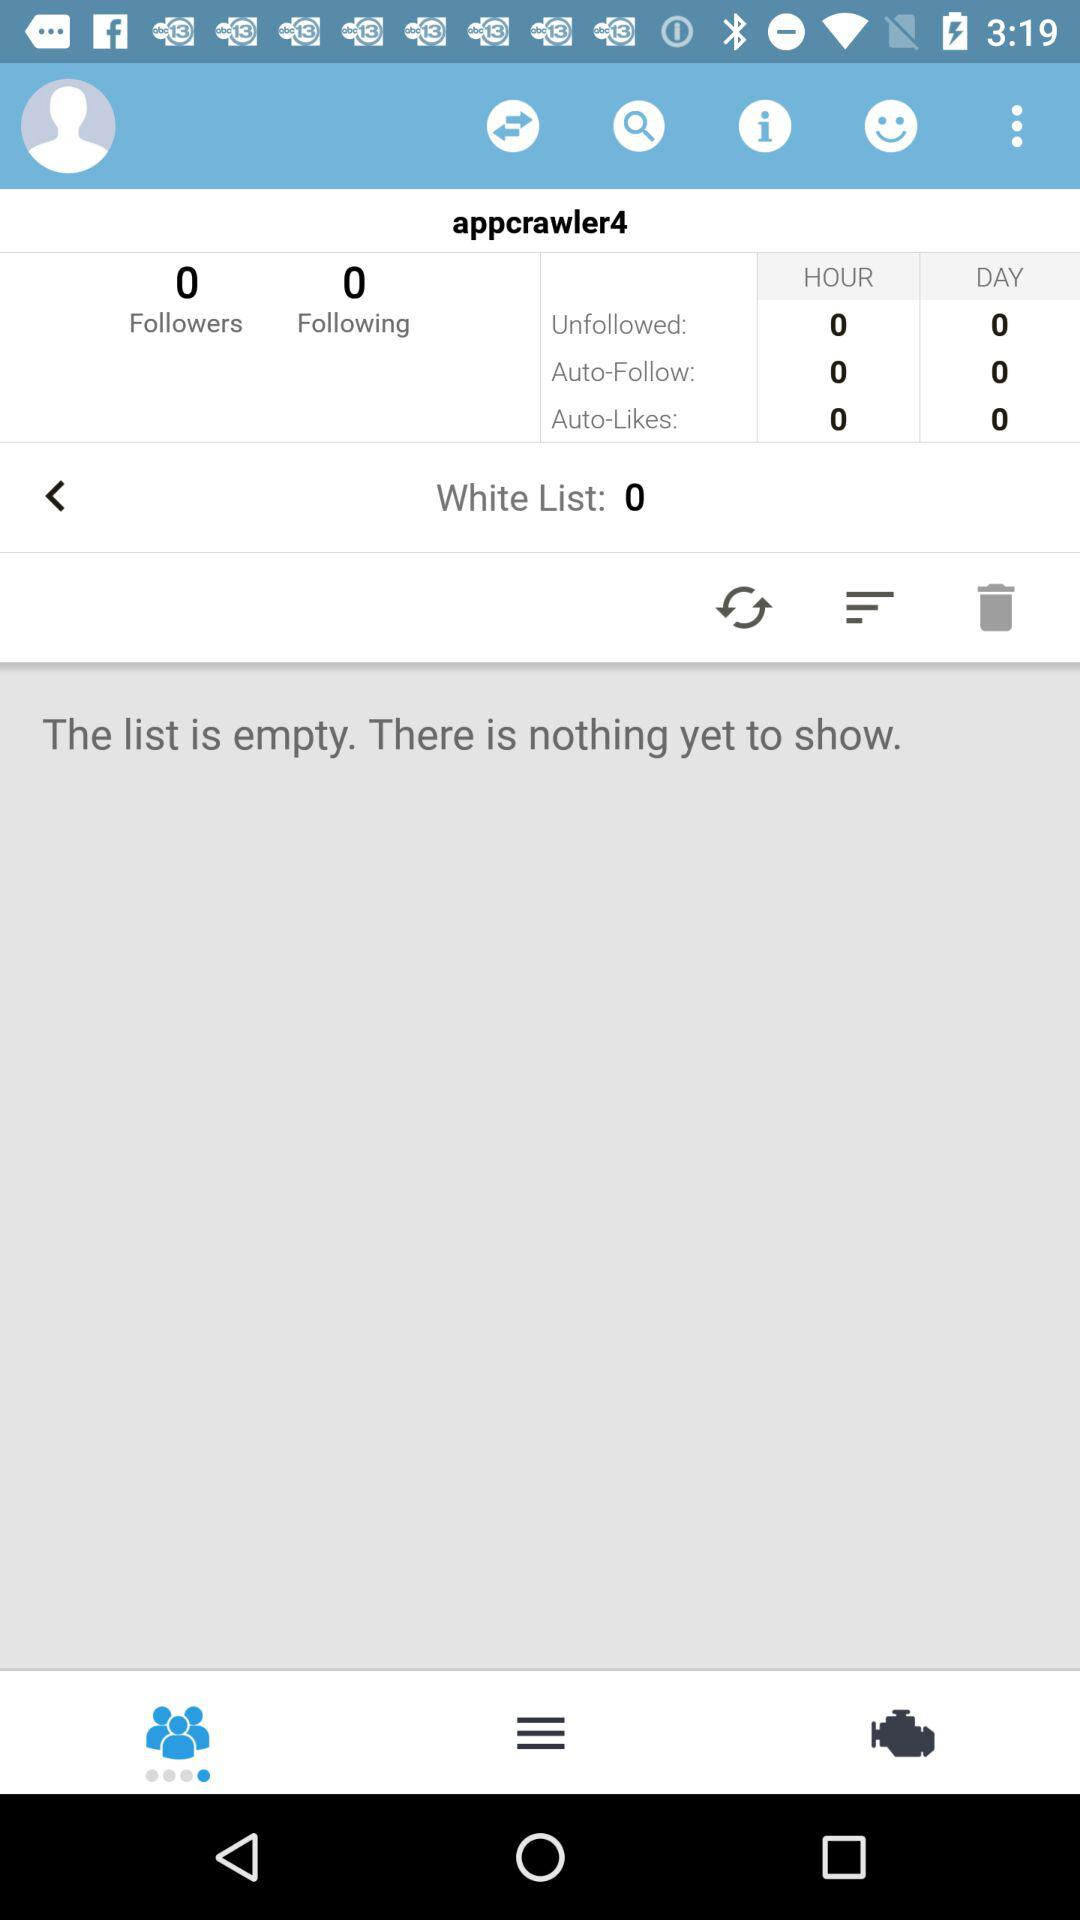How many followers of "appcrawler4" are there? There are 0 followers of "appcrawler4". 